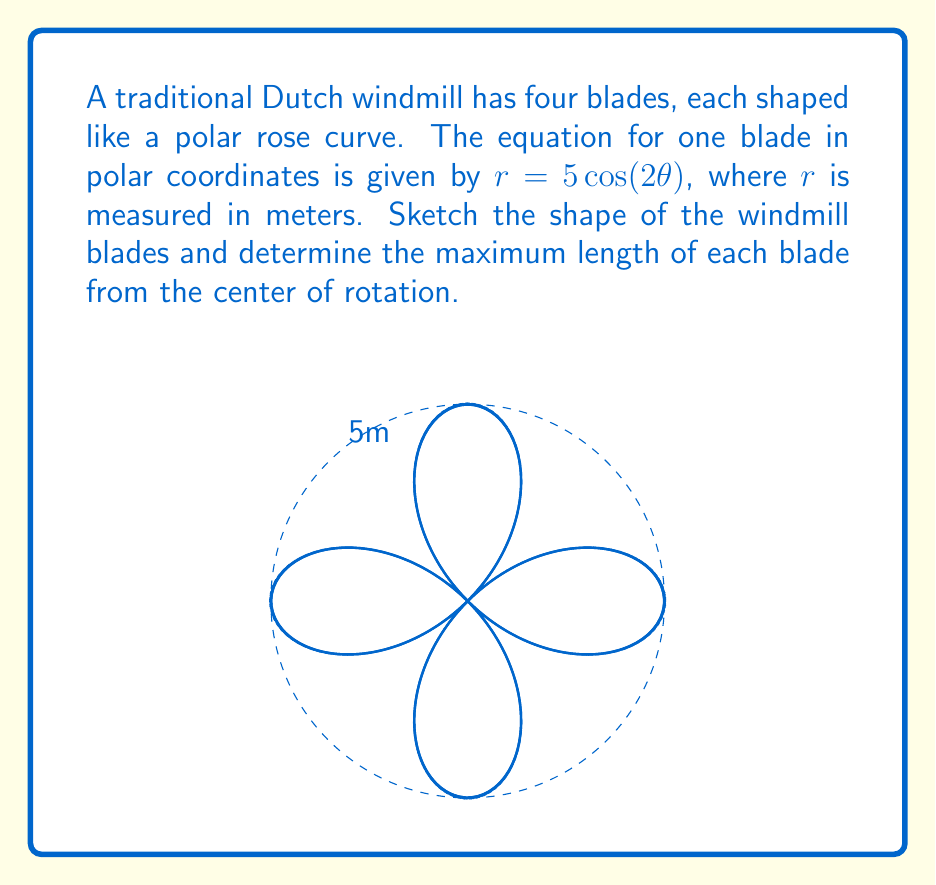Give your solution to this math problem. To solve this problem, let's follow these steps:

1) The equation $r = 5\cos(2\theta)$ represents a polar rose curve with four petals. This is because:
   - The factor of 2 inside the cosine function results in a 4-petal rose (general rule: $n$ petals for $\cos(n\theta)$ when $n$ is even).
   - The coefficient 5 determines the size of the rose.

2) To find the maximum length of each blade, we need to find the maximum value of $r$:
   - The cosine function has a maximum value of 1 when its argument is a multiple of $2\pi$.
   - Therefore, the maximum value of $r$ occurs when $\cos(2\theta) = 1$.
   - This happens when $2\theta = 0, 2\pi, 4\pi, ...$ or $\theta = 0, \pi, 2\pi, ...$

3) The maximum value of $r$ is:
   $r_{max} = 5 \cdot \cos(2 \cdot 0) = 5 \cdot 1 = 5$ meters

4) The shape of the windmill blades resembles a four-leaf clover, with each leaf representing one blade. The blades extend from the center to a maximum of 5 meters in four directions, aligned with the positive and negative x and y axes.

5) Note that the blades also extend in the negative direction (towards the center) due to the nature of the cosine function, but in practice, only the positive part would form the physical blade.
Answer: The maximum length of each blade is 5 meters. 